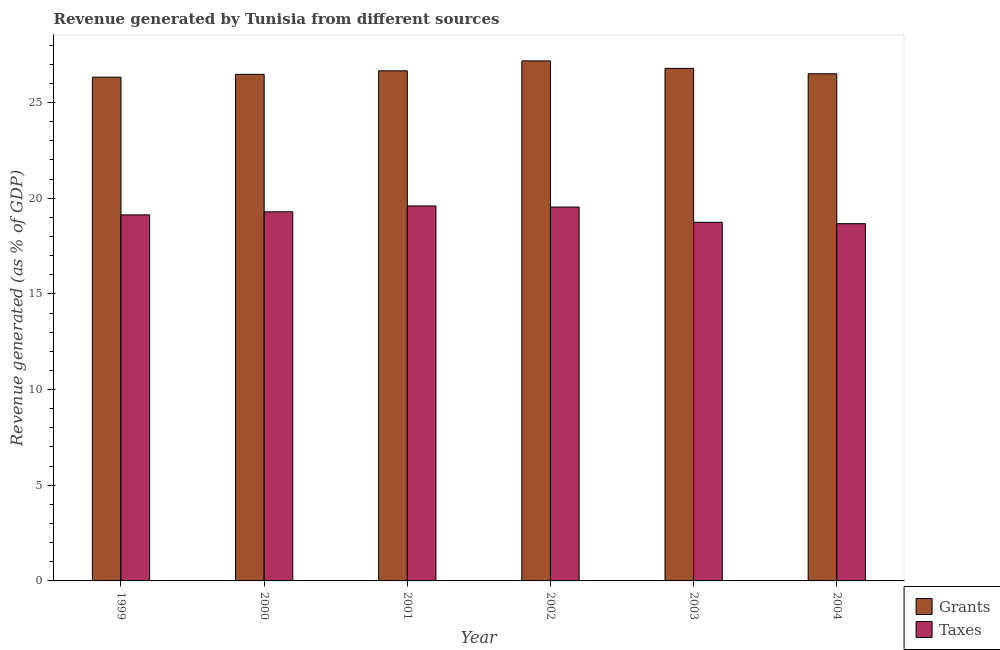How many different coloured bars are there?
Offer a very short reply. 2. Are the number of bars per tick equal to the number of legend labels?
Ensure brevity in your answer.  Yes. How many bars are there on the 1st tick from the left?
Provide a succinct answer. 2. What is the label of the 4th group of bars from the left?
Ensure brevity in your answer.  2002. What is the revenue generated by grants in 2000?
Your answer should be compact. 26.48. Across all years, what is the maximum revenue generated by taxes?
Offer a very short reply. 19.6. Across all years, what is the minimum revenue generated by grants?
Provide a succinct answer. 26.33. In which year was the revenue generated by grants maximum?
Ensure brevity in your answer.  2002. What is the total revenue generated by taxes in the graph?
Your answer should be very brief. 114.98. What is the difference between the revenue generated by taxes in 2002 and that in 2003?
Offer a very short reply. 0.8. What is the difference between the revenue generated by grants in 2004 and the revenue generated by taxes in 2002?
Provide a succinct answer. -0.67. What is the average revenue generated by taxes per year?
Provide a succinct answer. 19.16. In the year 2003, what is the difference between the revenue generated by taxes and revenue generated by grants?
Your response must be concise. 0. What is the ratio of the revenue generated by taxes in 2000 to that in 2003?
Ensure brevity in your answer.  1.03. Is the difference between the revenue generated by taxes in 2001 and 2003 greater than the difference between the revenue generated by grants in 2001 and 2003?
Offer a very short reply. No. What is the difference between the highest and the second highest revenue generated by grants?
Offer a terse response. 0.39. What is the difference between the highest and the lowest revenue generated by taxes?
Make the answer very short. 0.93. In how many years, is the revenue generated by taxes greater than the average revenue generated by taxes taken over all years?
Your response must be concise. 3. What does the 1st bar from the left in 2001 represents?
Your answer should be very brief. Grants. What does the 2nd bar from the right in 2003 represents?
Offer a very short reply. Grants. How many years are there in the graph?
Offer a terse response. 6. Does the graph contain grids?
Ensure brevity in your answer.  No. Where does the legend appear in the graph?
Your answer should be compact. Bottom right. How are the legend labels stacked?
Give a very brief answer. Vertical. What is the title of the graph?
Provide a short and direct response. Revenue generated by Tunisia from different sources. What is the label or title of the X-axis?
Your answer should be compact. Year. What is the label or title of the Y-axis?
Offer a terse response. Revenue generated (as % of GDP). What is the Revenue generated (as % of GDP) in Grants in 1999?
Your answer should be very brief. 26.33. What is the Revenue generated (as % of GDP) in Taxes in 1999?
Your answer should be compact. 19.13. What is the Revenue generated (as % of GDP) of Grants in 2000?
Keep it short and to the point. 26.48. What is the Revenue generated (as % of GDP) in Taxes in 2000?
Provide a succinct answer. 19.29. What is the Revenue generated (as % of GDP) of Grants in 2001?
Give a very brief answer. 26.66. What is the Revenue generated (as % of GDP) of Taxes in 2001?
Your response must be concise. 19.6. What is the Revenue generated (as % of GDP) in Grants in 2002?
Your answer should be very brief. 27.18. What is the Revenue generated (as % of GDP) of Taxes in 2002?
Give a very brief answer. 19.54. What is the Revenue generated (as % of GDP) in Grants in 2003?
Give a very brief answer. 26.79. What is the Revenue generated (as % of GDP) of Taxes in 2003?
Offer a very short reply. 18.75. What is the Revenue generated (as % of GDP) of Grants in 2004?
Your answer should be compact. 26.51. What is the Revenue generated (as % of GDP) in Taxes in 2004?
Keep it short and to the point. 18.67. Across all years, what is the maximum Revenue generated (as % of GDP) of Grants?
Provide a succinct answer. 27.18. Across all years, what is the maximum Revenue generated (as % of GDP) in Taxes?
Make the answer very short. 19.6. Across all years, what is the minimum Revenue generated (as % of GDP) in Grants?
Your answer should be very brief. 26.33. Across all years, what is the minimum Revenue generated (as % of GDP) in Taxes?
Offer a very short reply. 18.67. What is the total Revenue generated (as % of GDP) in Grants in the graph?
Your answer should be very brief. 159.94. What is the total Revenue generated (as % of GDP) of Taxes in the graph?
Give a very brief answer. 114.98. What is the difference between the Revenue generated (as % of GDP) of Grants in 1999 and that in 2000?
Offer a terse response. -0.15. What is the difference between the Revenue generated (as % of GDP) in Taxes in 1999 and that in 2000?
Provide a succinct answer. -0.16. What is the difference between the Revenue generated (as % of GDP) of Grants in 1999 and that in 2001?
Your response must be concise. -0.33. What is the difference between the Revenue generated (as % of GDP) in Taxes in 1999 and that in 2001?
Your response must be concise. -0.47. What is the difference between the Revenue generated (as % of GDP) of Grants in 1999 and that in 2002?
Offer a terse response. -0.85. What is the difference between the Revenue generated (as % of GDP) of Taxes in 1999 and that in 2002?
Offer a very short reply. -0.41. What is the difference between the Revenue generated (as % of GDP) in Grants in 1999 and that in 2003?
Your answer should be compact. -0.46. What is the difference between the Revenue generated (as % of GDP) of Taxes in 1999 and that in 2003?
Offer a very short reply. 0.39. What is the difference between the Revenue generated (as % of GDP) of Grants in 1999 and that in 2004?
Provide a short and direct response. -0.18. What is the difference between the Revenue generated (as % of GDP) in Taxes in 1999 and that in 2004?
Make the answer very short. 0.46. What is the difference between the Revenue generated (as % of GDP) in Grants in 2000 and that in 2001?
Provide a short and direct response. -0.18. What is the difference between the Revenue generated (as % of GDP) of Taxes in 2000 and that in 2001?
Provide a short and direct response. -0.3. What is the difference between the Revenue generated (as % of GDP) of Grants in 2000 and that in 2002?
Your response must be concise. -0.7. What is the difference between the Revenue generated (as % of GDP) of Taxes in 2000 and that in 2002?
Your response must be concise. -0.25. What is the difference between the Revenue generated (as % of GDP) in Grants in 2000 and that in 2003?
Offer a very short reply. -0.31. What is the difference between the Revenue generated (as % of GDP) of Taxes in 2000 and that in 2003?
Provide a short and direct response. 0.55. What is the difference between the Revenue generated (as % of GDP) in Grants in 2000 and that in 2004?
Give a very brief answer. -0.03. What is the difference between the Revenue generated (as % of GDP) in Taxes in 2000 and that in 2004?
Give a very brief answer. 0.62. What is the difference between the Revenue generated (as % of GDP) in Grants in 2001 and that in 2002?
Offer a very short reply. -0.52. What is the difference between the Revenue generated (as % of GDP) in Taxes in 2001 and that in 2002?
Make the answer very short. 0.06. What is the difference between the Revenue generated (as % of GDP) of Grants in 2001 and that in 2003?
Offer a very short reply. -0.13. What is the difference between the Revenue generated (as % of GDP) in Taxes in 2001 and that in 2003?
Make the answer very short. 0.85. What is the difference between the Revenue generated (as % of GDP) in Grants in 2001 and that in 2004?
Give a very brief answer. 0.15. What is the difference between the Revenue generated (as % of GDP) in Taxes in 2001 and that in 2004?
Make the answer very short. 0.93. What is the difference between the Revenue generated (as % of GDP) of Grants in 2002 and that in 2003?
Your answer should be compact. 0.39. What is the difference between the Revenue generated (as % of GDP) of Taxes in 2002 and that in 2003?
Provide a succinct answer. 0.8. What is the difference between the Revenue generated (as % of GDP) in Grants in 2002 and that in 2004?
Your answer should be compact. 0.67. What is the difference between the Revenue generated (as % of GDP) in Taxes in 2002 and that in 2004?
Provide a short and direct response. 0.87. What is the difference between the Revenue generated (as % of GDP) in Grants in 2003 and that in 2004?
Ensure brevity in your answer.  0.28. What is the difference between the Revenue generated (as % of GDP) of Taxes in 2003 and that in 2004?
Ensure brevity in your answer.  0.07. What is the difference between the Revenue generated (as % of GDP) of Grants in 1999 and the Revenue generated (as % of GDP) of Taxes in 2000?
Offer a terse response. 7.04. What is the difference between the Revenue generated (as % of GDP) of Grants in 1999 and the Revenue generated (as % of GDP) of Taxes in 2001?
Make the answer very short. 6.73. What is the difference between the Revenue generated (as % of GDP) in Grants in 1999 and the Revenue generated (as % of GDP) in Taxes in 2002?
Your answer should be very brief. 6.79. What is the difference between the Revenue generated (as % of GDP) in Grants in 1999 and the Revenue generated (as % of GDP) in Taxes in 2003?
Offer a very short reply. 7.58. What is the difference between the Revenue generated (as % of GDP) in Grants in 1999 and the Revenue generated (as % of GDP) in Taxes in 2004?
Keep it short and to the point. 7.66. What is the difference between the Revenue generated (as % of GDP) in Grants in 2000 and the Revenue generated (as % of GDP) in Taxes in 2001?
Your answer should be very brief. 6.88. What is the difference between the Revenue generated (as % of GDP) in Grants in 2000 and the Revenue generated (as % of GDP) in Taxes in 2002?
Give a very brief answer. 6.94. What is the difference between the Revenue generated (as % of GDP) of Grants in 2000 and the Revenue generated (as % of GDP) of Taxes in 2003?
Offer a terse response. 7.73. What is the difference between the Revenue generated (as % of GDP) of Grants in 2000 and the Revenue generated (as % of GDP) of Taxes in 2004?
Your answer should be compact. 7.8. What is the difference between the Revenue generated (as % of GDP) in Grants in 2001 and the Revenue generated (as % of GDP) in Taxes in 2002?
Offer a terse response. 7.12. What is the difference between the Revenue generated (as % of GDP) of Grants in 2001 and the Revenue generated (as % of GDP) of Taxes in 2003?
Your response must be concise. 7.92. What is the difference between the Revenue generated (as % of GDP) of Grants in 2001 and the Revenue generated (as % of GDP) of Taxes in 2004?
Give a very brief answer. 7.99. What is the difference between the Revenue generated (as % of GDP) of Grants in 2002 and the Revenue generated (as % of GDP) of Taxes in 2003?
Make the answer very short. 8.44. What is the difference between the Revenue generated (as % of GDP) in Grants in 2002 and the Revenue generated (as % of GDP) in Taxes in 2004?
Make the answer very short. 8.51. What is the difference between the Revenue generated (as % of GDP) in Grants in 2003 and the Revenue generated (as % of GDP) in Taxes in 2004?
Your answer should be very brief. 8.12. What is the average Revenue generated (as % of GDP) of Grants per year?
Provide a succinct answer. 26.66. What is the average Revenue generated (as % of GDP) of Taxes per year?
Your answer should be very brief. 19.16. In the year 1999, what is the difference between the Revenue generated (as % of GDP) of Grants and Revenue generated (as % of GDP) of Taxes?
Provide a succinct answer. 7.2. In the year 2000, what is the difference between the Revenue generated (as % of GDP) in Grants and Revenue generated (as % of GDP) in Taxes?
Keep it short and to the point. 7.18. In the year 2001, what is the difference between the Revenue generated (as % of GDP) of Grants and Revenue generated (as % of GDP) of Taxes?
Ensure brevity in your answer.  7.06. In the year 2002, what is the difference between the Revenue generated (as % of GDP) in Grants and Revenue generated (as % of GDP) in Taxes?
Your response must be concise. 7.64. In the year 2003, what is the difference between the Revenue generated (as % of GDP) of Grants and Revenue generated (as % of GDP) of Taxes?
Offer a very short reply. 8.04. In the year 2004, what is the difference between the Revenue generated (as % of GDP) in Grants and Revenue generated (as % of GDP) in Taxes?
Give a very brief answer. 7.84. What is the ratio of the Revenue generated (as % of GDP) in Taxes in 1999 to that in 2000?
Your answer should be compact. 0.99. What is the ratio of the Revenue generated (as % of GDP) in Grants in 1999 to that in 2001?
Your answer should be very brief. 0.99. What is the ratio of the Revenue generated (as % of GDP) of Taxes in 1999 to that in 2001?
Make the answer very short. 0.98. What is the ratio of the Revenue generated (as % of GDP) of Grants in 1999 to that in 2002?
Offer a very short reply. 0.97. What is the ratio of the Revenue generated (as % of GDP) of Taxes in 1999 to that in 2002?
Ensure brevity in your answer.  0.98. What is the ratio of the Revenue generated (as % of GDP) of Grants in 1999 to that in 2003?
Keep it short and to the point. 0.98. What is the ratio of the Revenue generated (as % of GDP) of Taxes in 1999 to that in 2003?
Offer a very short reply. 1.02. What is the ratio of the Revenue generated (as % of GDP) of Grants in 1999 to that in 2004?
Give a very brief answer. 0.99. What is the ratio of the Revenue generated (as % of GDP) in Taxes in 1999 to that in 2004?
Your answer should be very brief. 1.02. What is the ratio of the Revenue generated (as % of GDP) in Grants in 2000 to that in 2001?
Provide a succinct answer. 0.99. What is the ratio of the Revenue generated (as % of GDP) of Taxes in 2000 to that in 2001?
Make the answer very short. 0.98. What is the ratio of the Revenue generated (as % of GDP) of Grants in 2000 to that in 2002?
Your answer should be very brief. 0.97. What is the ratio of the Revenue generated (as % of GDP) of Taxes in 2000 to that in 2002?
Make the answer very short. 0.99. What is the ratio of the Revenue generated (as % of GDP) in Grants in 2000 to that in 2003?
Keep it short and to the point. 0.99. What is the ratio of the Revenue generated (as % of GDP) of Taxes in 2000 to that in 2003?
Ensure brevity in your answer.  1.03. What is the ratio of the Revenue generated (as % of GDP) of Grants in 2000 to that in 2004?
Your answer should be compact. 1. What is the ratio of the Revenue generated (as % of GDP) of Taxes in 2000 to that in 2004?
Ensure brevity in your answer.  1.03. What is the ratio of the Revenue generated (as % of GDP) of Grants in 2001 to that in 2002?
Provide a short and direct response. 0.98. What is the ratio of the Revenue generated (as % of GDP) in Taxes in 2001 to that in 2002?
Ensure brevity in your answer.  1. What is the ratio of the Revenue generated (as % of GDP) of Taxes in 2001 to that in 2003?
Make the answer very short. 1.05. What is the ratio of the Revenue generated (as % of GDP) in Grants in 2001 to that in 2004?
Provide a short and direct response. 1.01. What is the ratio of the Revenue generated (as % of GDP) in Taxes in 2001 to that in 2004?
Your response must be concise. 1.05. What is the ratio of the Revenue generated (as % of GDP) of Grants in 2002 to that in 2003?
Provide a succinct answer. 1.01. What is the ratio of the Revenue generated (as % of GDP) of Taxes in 2002 to that in 2003?
Offer a terse response. 1.04. What is the ratio of the Revenue generated (as % of GDP) of Grants in 2002 to that in 2004?
Keep it short and to the point. 1.03. What is the ratio of the Revenue generated (as % of GDP) in Taxes in 2002 to that in 2004?
Your answer should be very brief. 1.05. What is the ratio of the Revenue generated (as % of GDP) in Grants in 2003 to that in 2004?
Make the answer very short. 1.01. What is the ratio of the Revenue generated (as % of GDP) in Taxes in 2003 to that in 2004?
Your response must be concise. 1. What is the difference between the highest and the second highest Revenue generated (as % of GDP) in Grants?
Ensure brevity in your answer.  0.39. What is the difference between the highest and the second highest Revenue generated (as % of GDP) of Taxes?
Provide a short and direct response. 0.06. What is the difference between the highest and the lowest Revenue generated (as % of GDP) in Grants?
Your answer should be compact. 0.85. What is the difference between the highest and the lowest Revenue generated (as % of GDP) in Taxes?
Give a very brief answer. 0.93. 